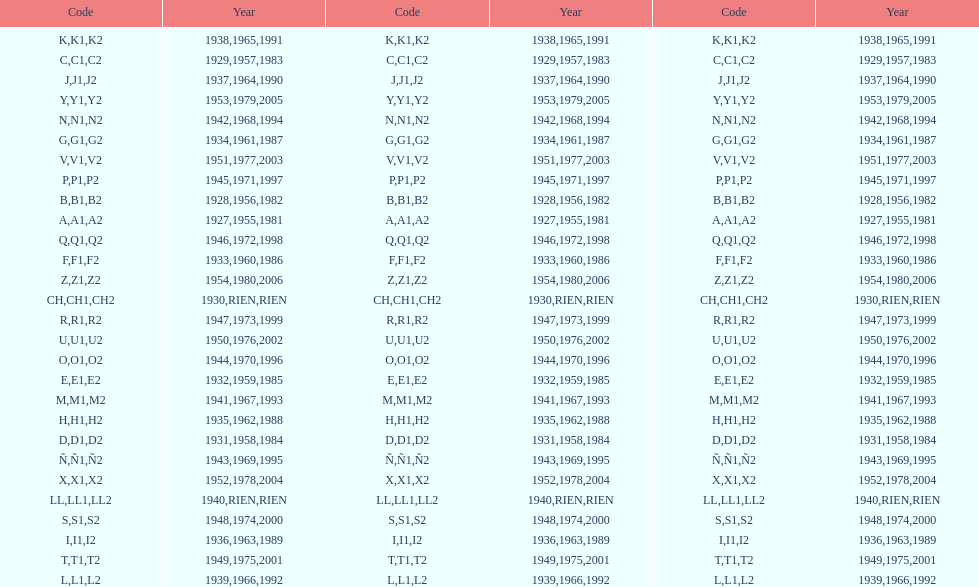Other than 1927 what year did the code start with a? 1955, 1981. 